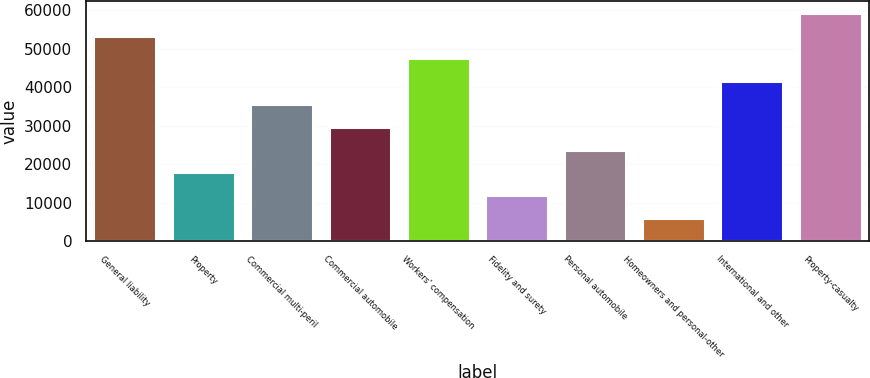<chart> <loc_0><loc_0><loc_500><loc_500><bar_chart><fcel>General liability<fcel>Property<fcel>Commercial multi-peril<fcel>Commercial automobile<fcel>Workers' compensation<fcel>Fidelity and surety<fcel>Personal automobile<fcel>Homeowners and personal-other<fcel>International and other<fcel>Property-casualty<nl><fcel>53367.8<fcel>17846.6<fcel>35607.2<fcel>29687<fcel>47447.6<fcel>11926.4<fcel>23766.8<fcel>6006.2<fcel>41527.4<fcel>59288<nl></chart> 